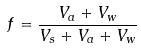Convert formula to latex. <formula><loc_0><loc_0><loc_500><loc_500>f = \frac { V _ { a } + V _ { w } } { V _ { s } + V _ { a } + V _ { w } }</formula> 